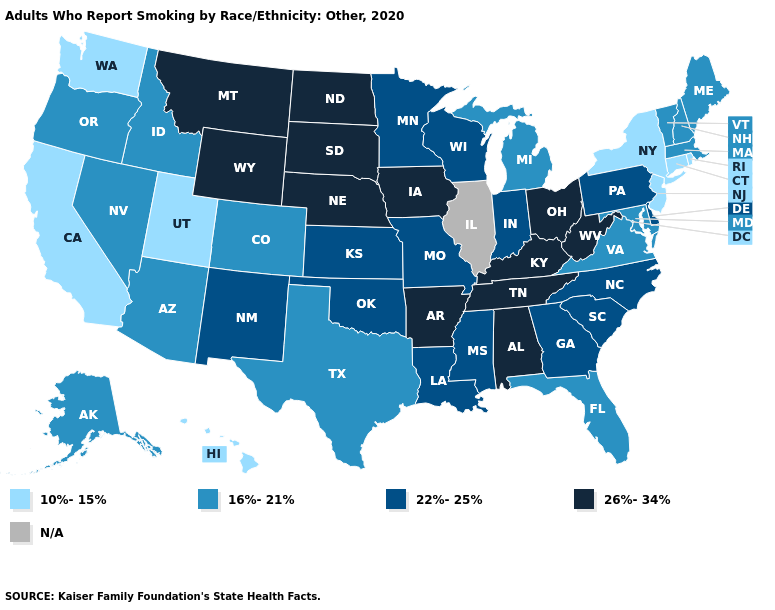What is the value of Michigan?
Give a very brief answer. 16%-21%. Is the legend a continuous bar?
Answer briefly. No. What is the lowest value in the West?
Be succinct. 10%-15%. Among the states that border New Mexico , does Colorado have the highest value?
Keep it brief. No. Does Tennessee have the lowest value in the South?
Answer briefly. No. Which states hav the highest value in the South?
Concise answer only. Alabama, Arkansas, Kentucky, Tennessee, West Virginia. What is the highest value in the West ?
Answer briefly. 26%-34%. Name the states that have a value in the range N/A?
Answer briefly. Illinois. What is the lowest value in the USA?
Short answer required. 10%-15%. Does the map have missing data?
Quick response, please. Yes. Name the states that have a value in the range 10%-15%?
Short answer required. California, Connecticut, Hawaii, New Jersey, New York, Rhode Island, Utah, Washington. 